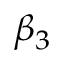<formula> <loc_0><loc_0><loc_500><loc_500>\beta _ { 3 }</formula> 